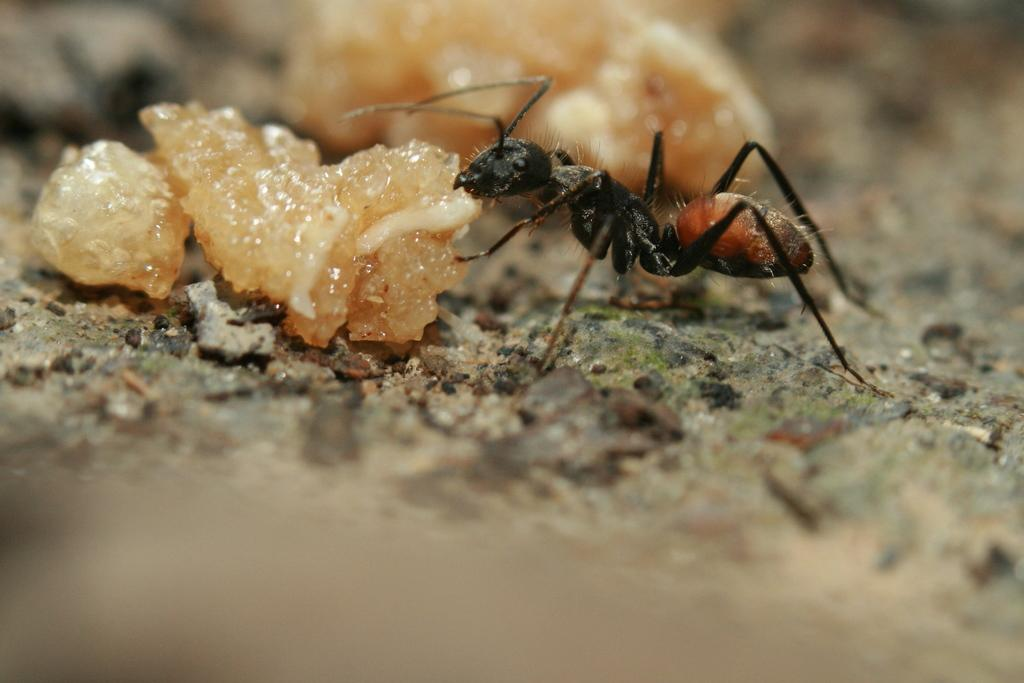What type of creature can be seen in the image? There is an ant in the image. What else is present in the image besides the ant? There are food items and stones on the ground in the image. Where is the grandmother sitting in the image? There is no grandmother present in the image. What type of bridge can be seen in the image? There is no bridge present in the image. 